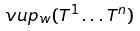Convert formula to latex. <formula><loc_0><loc_0><loc_500><loc_500>\ v u p _ { w } ( T ^ { 1 } \dots T ^ { n } )</formula> 